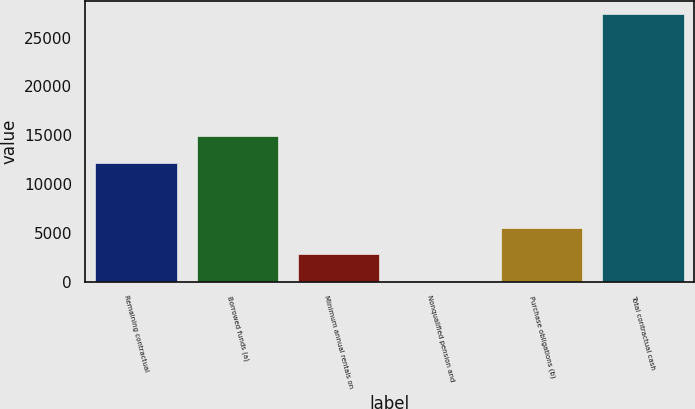Convert chart to OTSL. <chart><loc_0><loc_0><loc_500><loc_500><bar_chart><fcel>Remaining contractual<fcel>Borrowed funds (a)<fcel>Minimum annual rentals on<fcel>Nonqualified pension and<fcel>Purchase obligations (b)<fcel>Total contractual cash<nl><fcel>12200<fcel>14935.6<fcel>2791.6<fcel>56<fcel>5527.2<fcel>27412<nl></chart> 